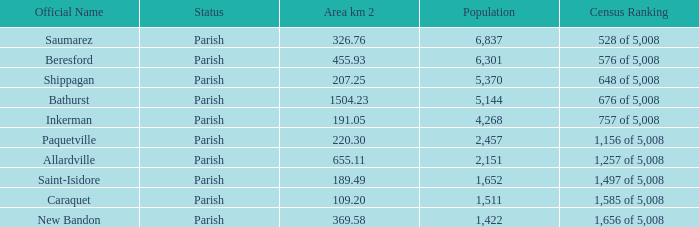76 km²? 1422.0. 